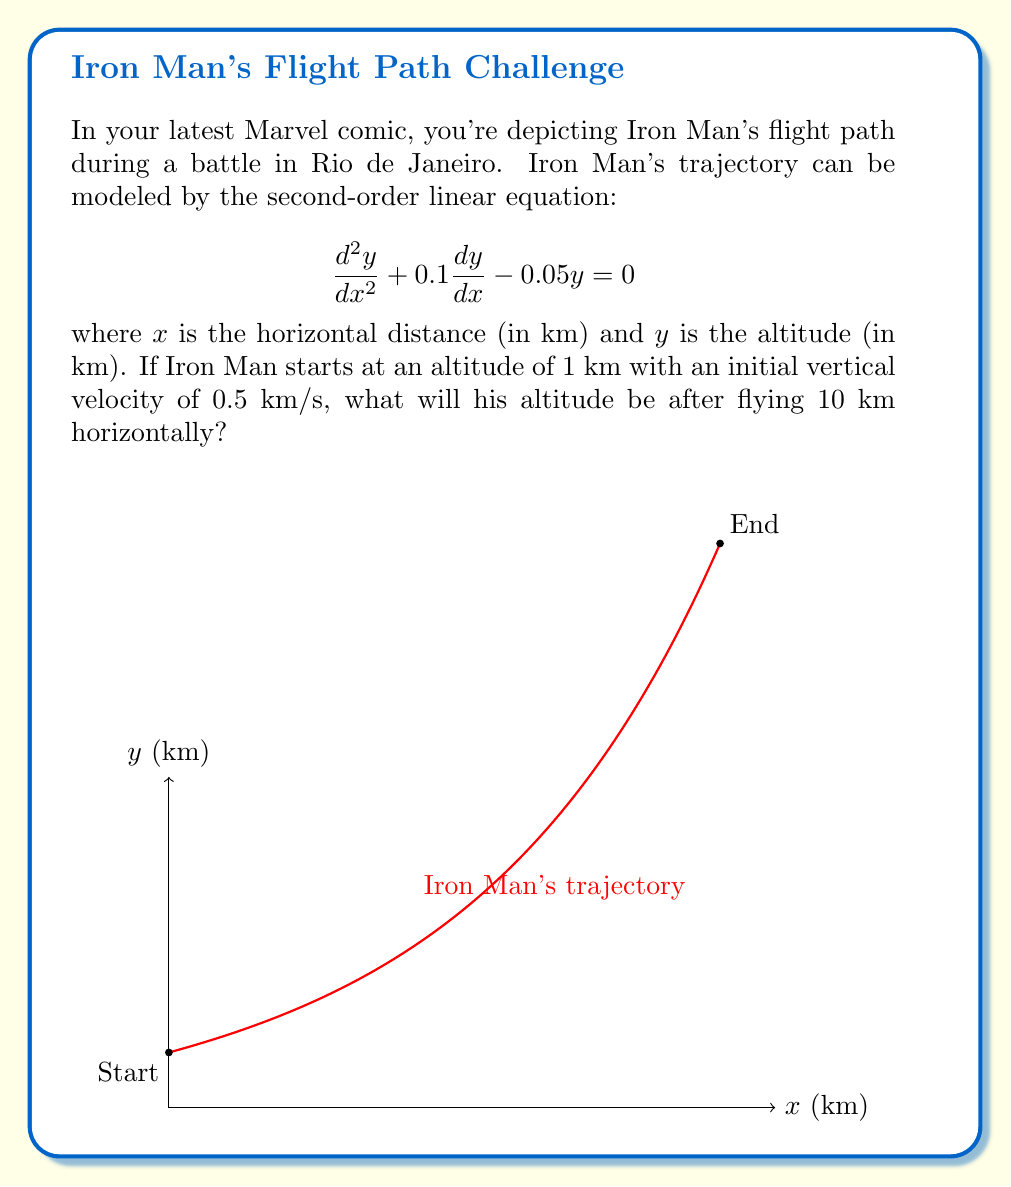Provide a solution to this math problem. Let's solve this step-by-step:

1) The general solution for this second-order linear equation is:
   $$y = C_1e^{r_1x} + C_2e^{r_2x}$$
   where $r_1$ and $r_2$ are roots of the characteristic equation.

2) The characteristic equation is:
   $$r^2 + 0.1r - 0.05 = 0$$

3) Solving this quadratic equation:
   $$r = \frac{-0.1 \pm \sqrt{0.1^2 + 4(0.05)}}{2} = \frac{-0.1 \pm \sqrt{0.21}}{2}$$
   $$r_1 \approx 0.224, r_2 \approx -0.324$$

4) So the general solution is:
   $$y = C_1e^{0.224x} + C_2e^{-0.324x}$$

5) We need to find $C_1$ and $C_2$ using initial conditions:
   At $x=0$, $y=1$ and $\frac{dy}{dx}=0.5$

6) Using $y(0)=1$:
   $$1 = C_1 + C_2$$

7) Using $\frac{dy}{dx}(0)=0.5$:
   $$0.5 = 0.224C_1 - 0.324C_2$$

8) Solving these equations:
   $$C_1 \approx 1.090, C_2 \approx -0.090$$

9) Therefore, the particular solution is:
   $$y = 1.090e^{0.224x} - 0.090e^{-0.324x}$$

10) At $x=10$:
    $$y = 1.090e^{0.224(10)} - 0.090e^{-0.324(10)} \approx 9.715$$

Thus, Iron Man's altitude after flying 10 km horizontally will be approximately 9.715 km.
Answer: $9.715$ km 